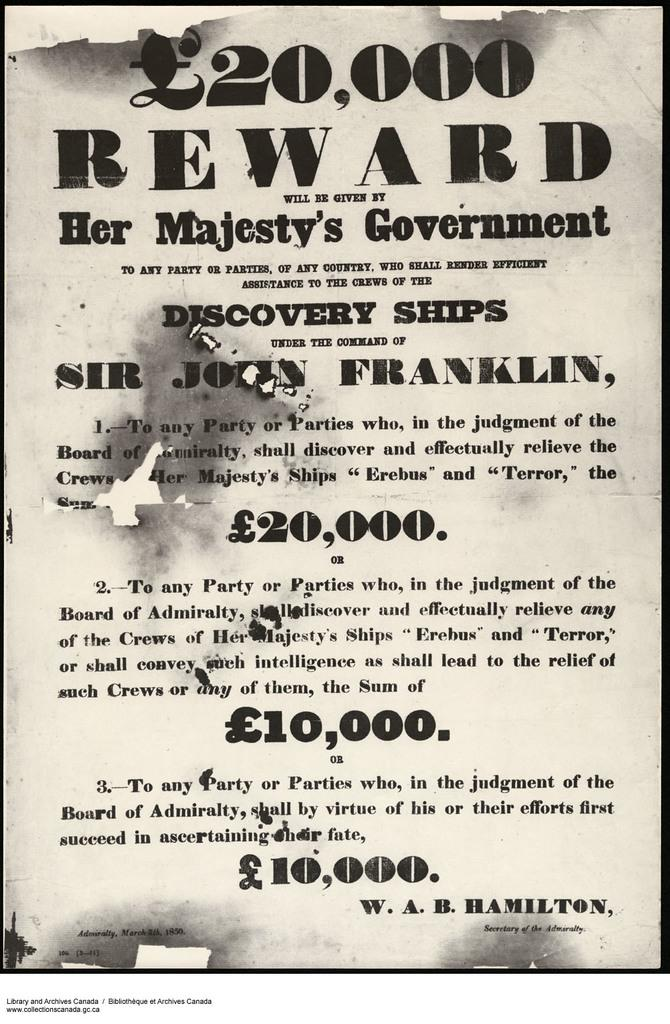Provide a one-sentence caption for the provided image. A reward poster to remove the crews of several ships. 